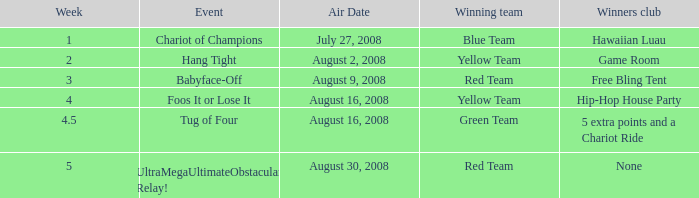Which Winners club has a Week of 4.5? 5 extra points and a Chariot Ride. 